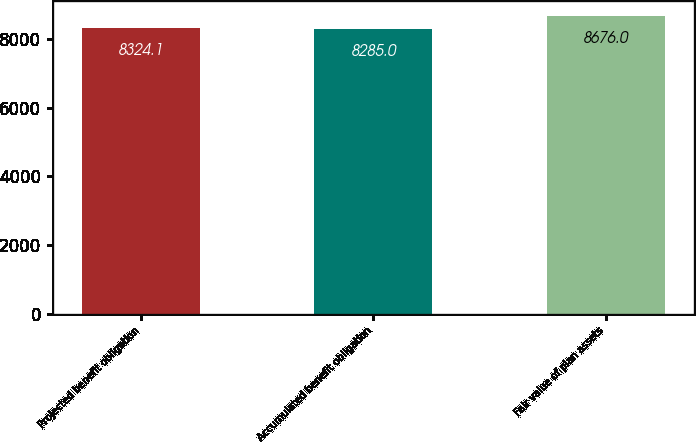Convert chart to OTSL. <chart><loc_0><loc_0><loc_500><loc_500><bar_chart><fcel>Projected benefit obligation<fcel>Accumulated benefit obligation<fcel>Fair value of plan assets<nl><fcel>8324.1<fcel>8285<fcel>8676<nl></chart> 